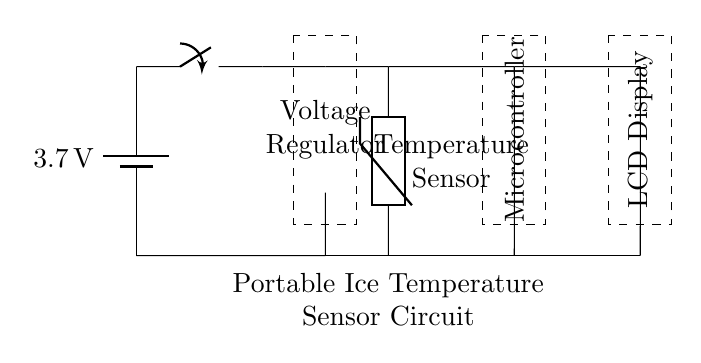What is the voltage of the battery? The voltage of the battery is stated directly in the circuit as 3.7 volts.
Answer: 3.7 volts What component regulates the voltage in this circuit? The component that regulates the voltage in this circuit is labeled as the Voltage Regulator, which is represented in a dashed rectangle within the circuit.
Answer: Voltage Regulator How many main components are present in this circuit? The main components visible in the circuit diagram include the battery, voltage regulator, temperature sensor, microcontroller, and LCD display, totaling five components.
Answer: Five components What type of sensor is used in this circuit? The type of sensor used in this circuit is a thermistor, which is designed for temperature measurement and is indicated in the circuit diagram.
Answer: Thermistor Which component displays the temperature readings? The component that displays the temperature readings is the LCD Display, which is shown as a dashed rectangle in the circuit diagram, connected to the microcontroller.
Answer: LCD Display What is the purpose of the microcontroller in this circuit? The microcontroller serves as the processing unit that receives data from the temperature sensor and controls the display of this information on the LCD. This function ties together information gathering and output, making it essential for the operation of the sensor circuit.
Answer: Processing unit How are the components connected in this circuit? The components are connected in series, with the battery supplying power to the voltage regulator, which then connects to the temperature sensor, followed by the microcontroller, and finally the LCD display. This series connection allows for a streamlined flow of current and signals throughout the circuit.
Answer: In series 